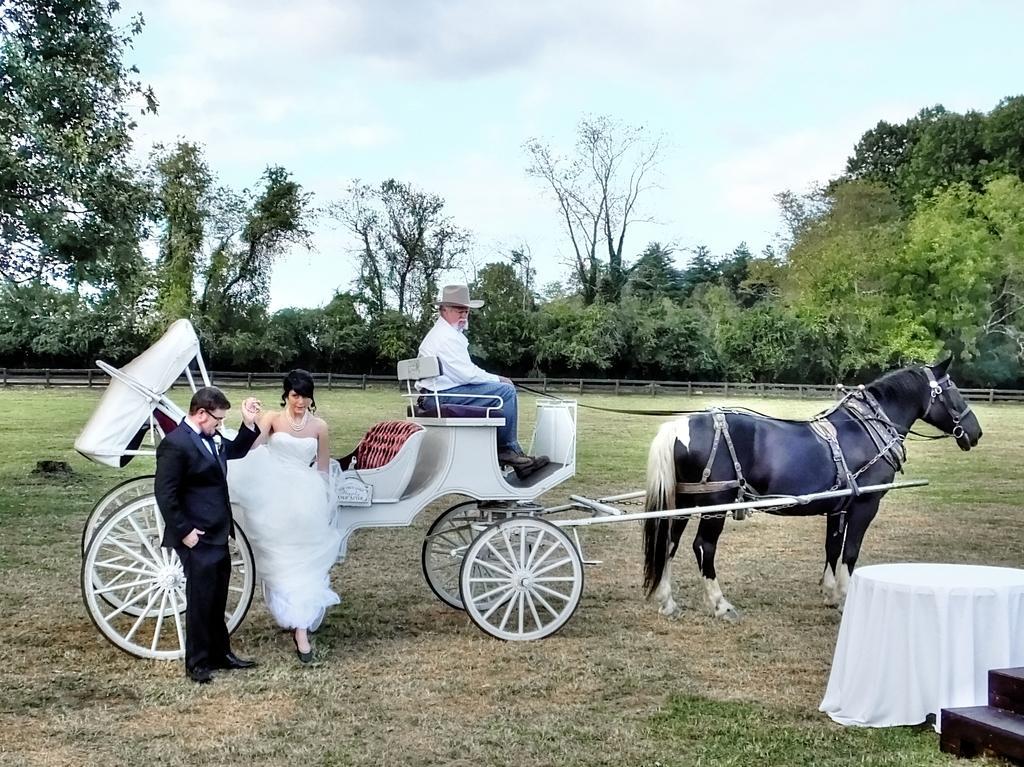How would you summarize this image in a sentence or two? In this image there is a cart tied to a horse which is standing on the grass land. A person wearing a white shirt is sitting on the cart. He is wearing a cap. Left side there is a person wearing a suit. He is holding the hand of a woman. She is wearing a white dress. Right side there is a table covered with a cloth. Beside there are stairs. There is fence. Behind there are few trees. Top of the image there is sky. 